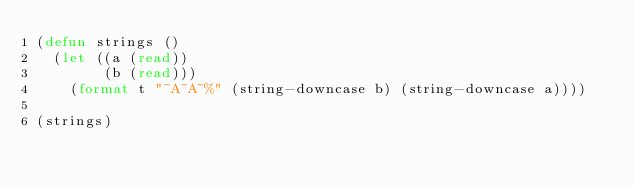<code> <loc_0><loc_0><loc_500><loc_500><_Lisp_>(defun strings ()
  (let ((a (read))
        (b (read)))
    (format t "~A~A~%" (string-downcase b) (string-downcase a))))

(strings)
</code> 